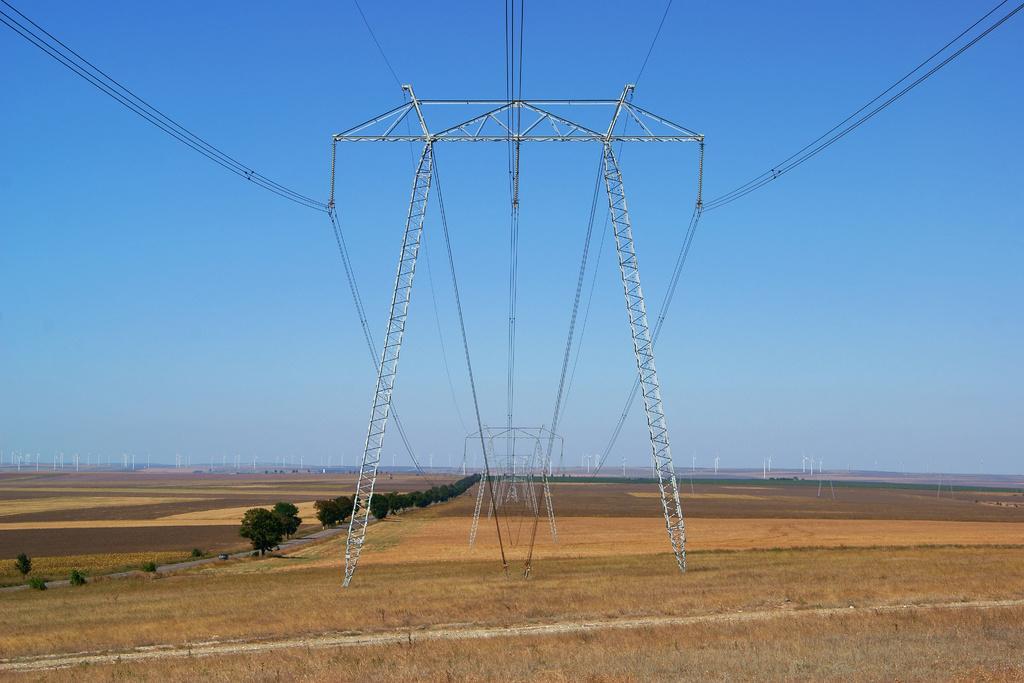Could you give a brief overview of what you see in this image? In this image we can see electric towers, electric cables, grass, trees and sky. In the background we can see windmills. 